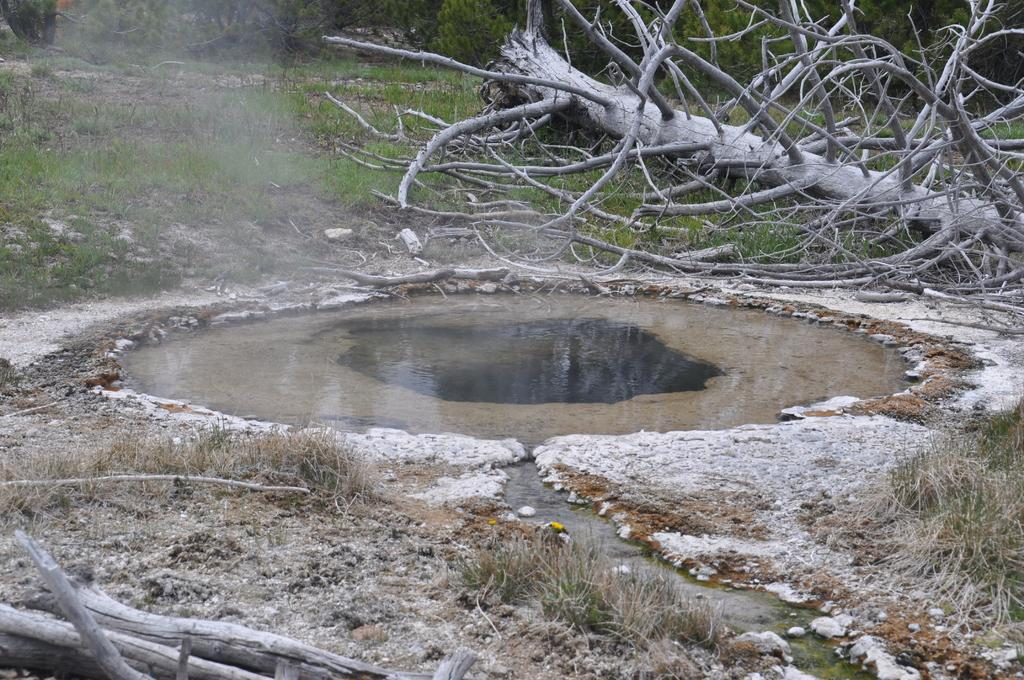What type of vegetation is present in the image? There is grass in the image. What natural feature can be seen in the image? There is a fallen tree in the image. What can be seen in the background of the image? There is water visible in the image. What objects are on the ground in the image? There are wooden branches on the ground in the image. What type of voice can be heard coming from the pizzas in the image? There are no pizzas present in the image, so it's not possible to determine if they have a voice or not. 